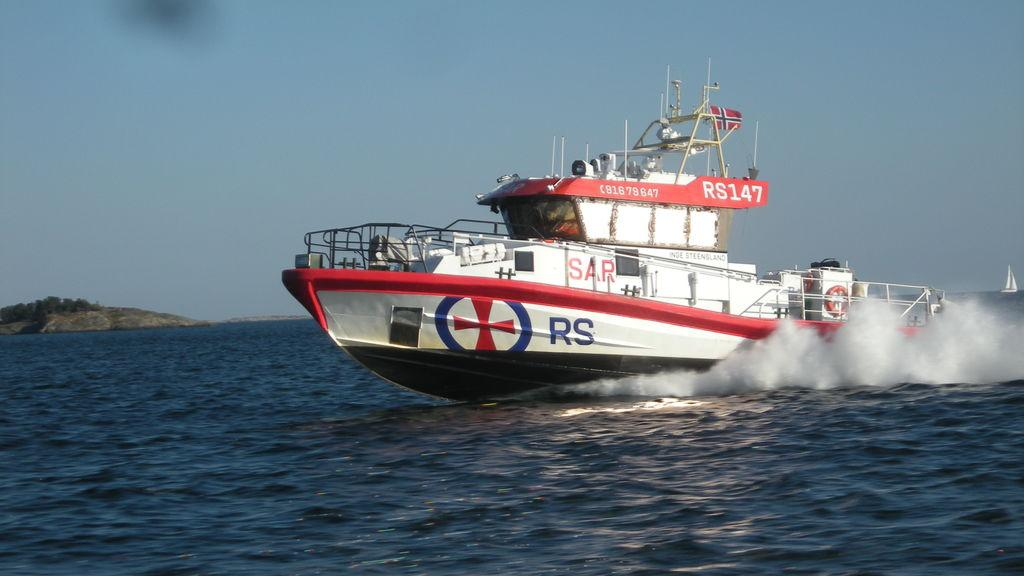What is the main subject of the image? The main subject of the image is water. What is present in the water? There is a boat in the water. What can be seen in the air above the water? There is smoke in the image. What type of vegetation is visible in the background? There are trees in the background of the image. What is visible at the top of the image? The sky is visible at the top of the image. What shape is the smoke forming in the image? The provided facts do not mention the shape of the smoke, so we cannot determine its shape from the image. 